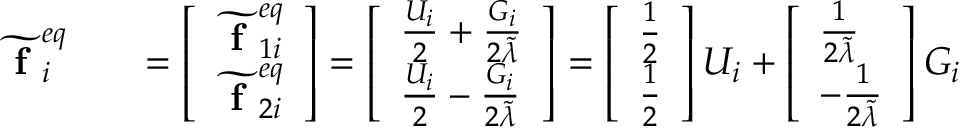Convert formula to latex. <formula><loc_0><loc_0><loc_500><loc_500>\begin{array} { r l r } { \widetilde { f } _ { i } ^ { e q } } & { = \left [ \begin{array} { l } { \widetilde { f } _ { 1 i } ^ { e q } } \\ { \widetilde { f } _ { 2 i } ^ { e q } } \end{array} \right ] = \left [ \begin{array} { l } { \frac { U _ { i } } { 2 } + \frac { G _ { i } } { 2 \widetilde { \lambda } } } \\ { \frac { U _ { i } } { 2 } - \frac { G _ { i } } { 2 \widetilde { \lambda } } } \end{array} \right ] = \left [ \begin{array} { l } { \frac { 1 } { 2 } } \\ { \frac { 1 } { 2 } } \end{array} \right ] U _ { i } + \left [ \begin{array} { l } { \frac { 1 } { 2 \widetilde { \lambda } } } \\ { - \frac { 1 } { 2 \widetilde { \lambda } } } \end{array} \right ] G _ { i } } \end{array}</formula> 